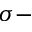<formula> <loc_0><loc_0><loc_500><loc_500>\sigma -</formula> 